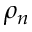<formula> <loc_0><loc_0><loc_500><loc_500>\rho _ { n }</formula> 